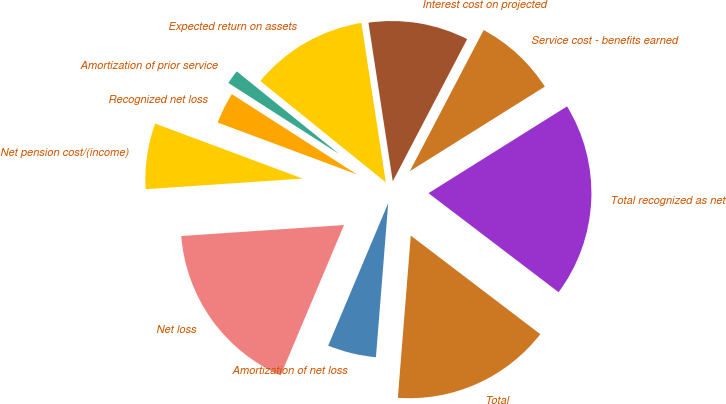<chart> <loc_0><loc_0><loc_500><loc_500><pie_chart><fcel>Service cost - benefits earned<fcel>Interest cost on projected<fcel>Expected return on assets<fcel>Amortization of prior service<fcel>Recognized net loss<fcel>Net pension cost/(income)<fcel>Net loss<fcel>Amortization of net loss<fcel>Total<fcel>Total recognized as net<nl><fcel>8.42%<fcel>10.09%<fcel>11.77%<fcel>1.73%<fcel>3.4%<fcel>6.75%<fcel>17.58%<fcel>5.08%<fcel>15.91%<fcel>19.26%<nl></chart> 